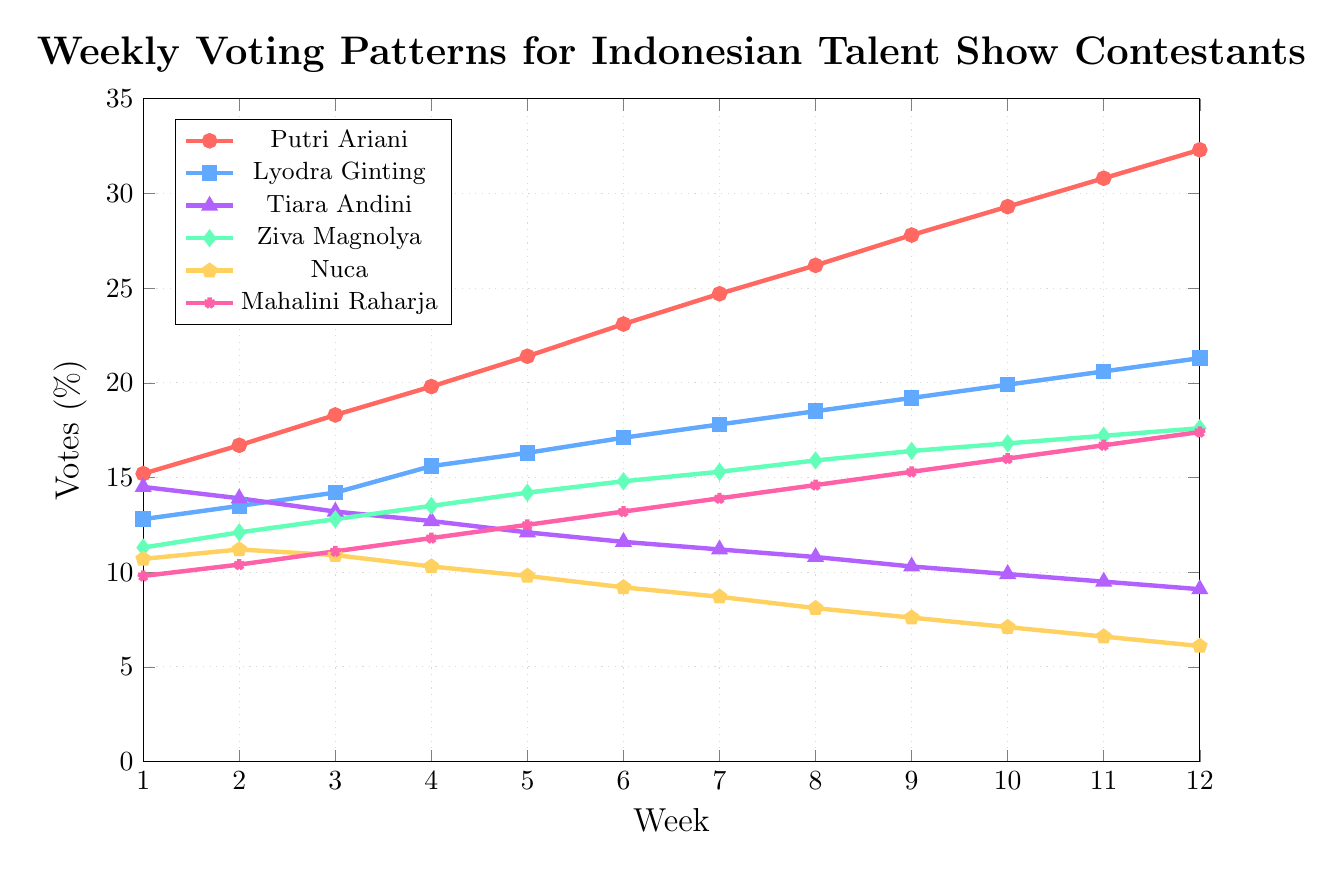Which contestant received the highest percentage of votes in Week 6? To find the contestant with the highest percentage of votes in Week 6, look for the maximum value on the vertical axis at Week 6.
Answer: Putri Ariani Compare the voting percentages of Tiara Andini and Ziva Magnolya in Week 1. Who received more votes? Observe the values at Week 1 for both contestants. Tiara Andini received 14.5%, and Ziva Magnolya received 11.3%.
Answer: Tiara Andini By how much did Putri Ariani's votes increase from Week 1 to Week 12? Calculate the difference between Putri Ariani's votes in Week 12 and Week 1 (32.3% - 15.2%).
Answer: 17.1% Which contestant showed a decrease in voting percentage over the weeks? Identify the contestant whose voting percentages decrease from Week 1 through Week 12.
Answer: Nuca Who had the smallest increase in votes from Week 1 to Week 12? Determine the increase for each contestant from Week 1 to Week 12, then identify the smallest: \[ \text{Tiara Andini: }9.1\% - 14.5\% = -5.4\% \] \[ \text{Nuca: }6.1\% - 10.7\% = -4.6\% \] \[ \text{Lyodra Ginting: }21.3\% - 12.8\% = 8.5\% \] \[ \text{Putri Ariani: }32.3\% - 15.2\% = 17.1\% \] \[ \text{Ziva Magnolya: }17.6\% - 11.3\% = 6.3\% \]
Answer: Nuca Between Weeks 5 and 6, which contestant had the largest increase in votes? Observe the increase between Weeks 5 and 6 for all contestants: \[ \text{Putri Ariani: }23.1\% - 21.4\% = 1.7\% \] \[ \text{Lyodra Ginting: }17.1\% - 16.3\% = 0.8\% \] \[ \text{Tiara Andini: }11.6\% - 12.1\% = -0.5\% \] \[ \text{Ziva Magnolya: }14.8\% - 14.2\% = 0.6\% \] \[ \text{Nuca: }9.2\% - 9.8\% = -0.6\% \] \[ \text{Mahalini Raharja: }13.2\% - 12.5\% = 0.7\% \]
Answer: Putri Ariani How many contestants have voting percentages above 20% by the end of Week 12? Count the number of contestants whose percentages are above 20% in Week 12.
Answer: 2 (Putri Ariani and Lyodra Ginting) Which contestant had a consistently increasing voting pattern throughout the season? Identify the contestant whose voting percentages are consistently increasing from Week 1 to Week 12.
Answer: Putri Ariani What is the average vote percentage for Ziva Magnolya from Week 1 to Week 12? Calculate the mean of Ziva Magnolya’s vote percentages from Week 1 to Week 12 (sum of percentages divided by the number of weeks).
Answer: 14.45% Compare Mahalini Raharja's voting trend to that of Tiara Andini. How do their trends differ? Observe voting patterns: Mahalini's votes increase over time, whereas Tiara's votes decrease.
Answer: Mahalini increased, Tiara decreased 